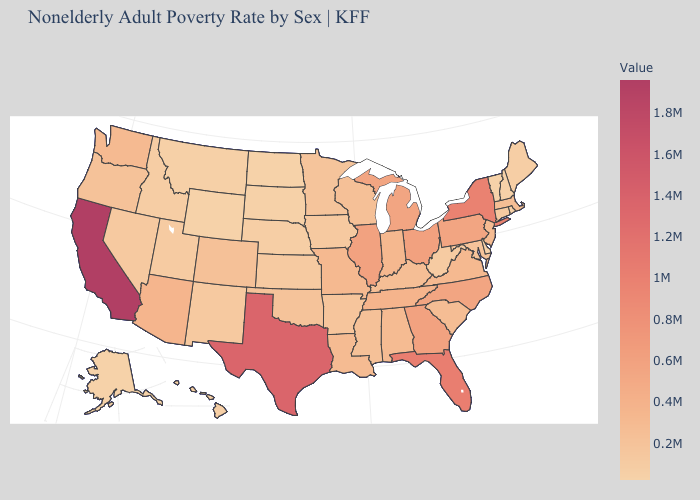Does the map have missing data?
Answer briefly. No. Among the states that border New Hampshire , does Massachusetts have the lowest value?
Answer briefly. No. Is the legend a continuous bar?
Be succinct. Yes. Does Texas have the highest value in the South?
Give a very brief answer. Yes. Which states have the lowest value in the West?
Be succinct. Wyoming. Among the states that border North Carolina , does South Carolina have the highest value?
Give a very brief answer. No. Which states have the lowest value in the USA?
Write a very short answer. Vermont. 